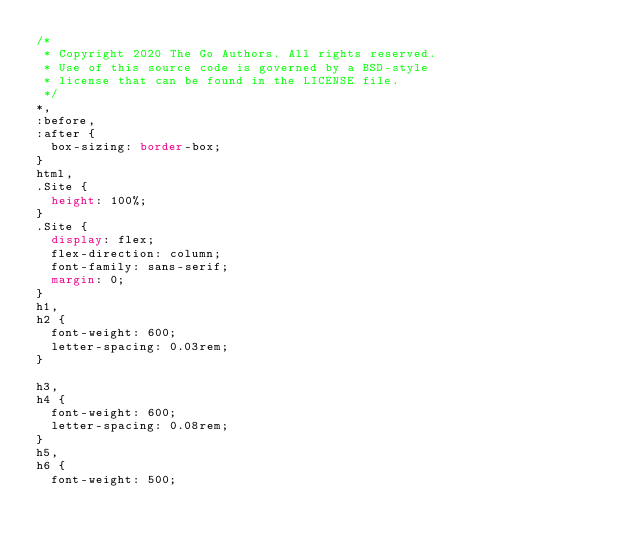<code> <loc_0><loc_0><loc_500><loc_500><_CSS_>/*
 * Copyright 2020 The Go Authors. All rights reserved.
 * Use of this source code is governed by a BSD-style
 * license that can be found in the LICENSE file.
 */
*,
:before,
:after {
  box-sizing: border-box;
}
html,
.Site {
  height: 100%;
}
.Site {
  display: flex;
  flex-direction: column;
  font-family: sans-serif;
  margin: 0;
}
h1,
h2 {
  font-weight: 600;
  letter-spacing: 0.03rem;
}

h3,
h4 {
  font-weight: 600;
  letter-spacing: 0.08rem;
}
h5,
h6 {
  font-weight: 500;</code> 